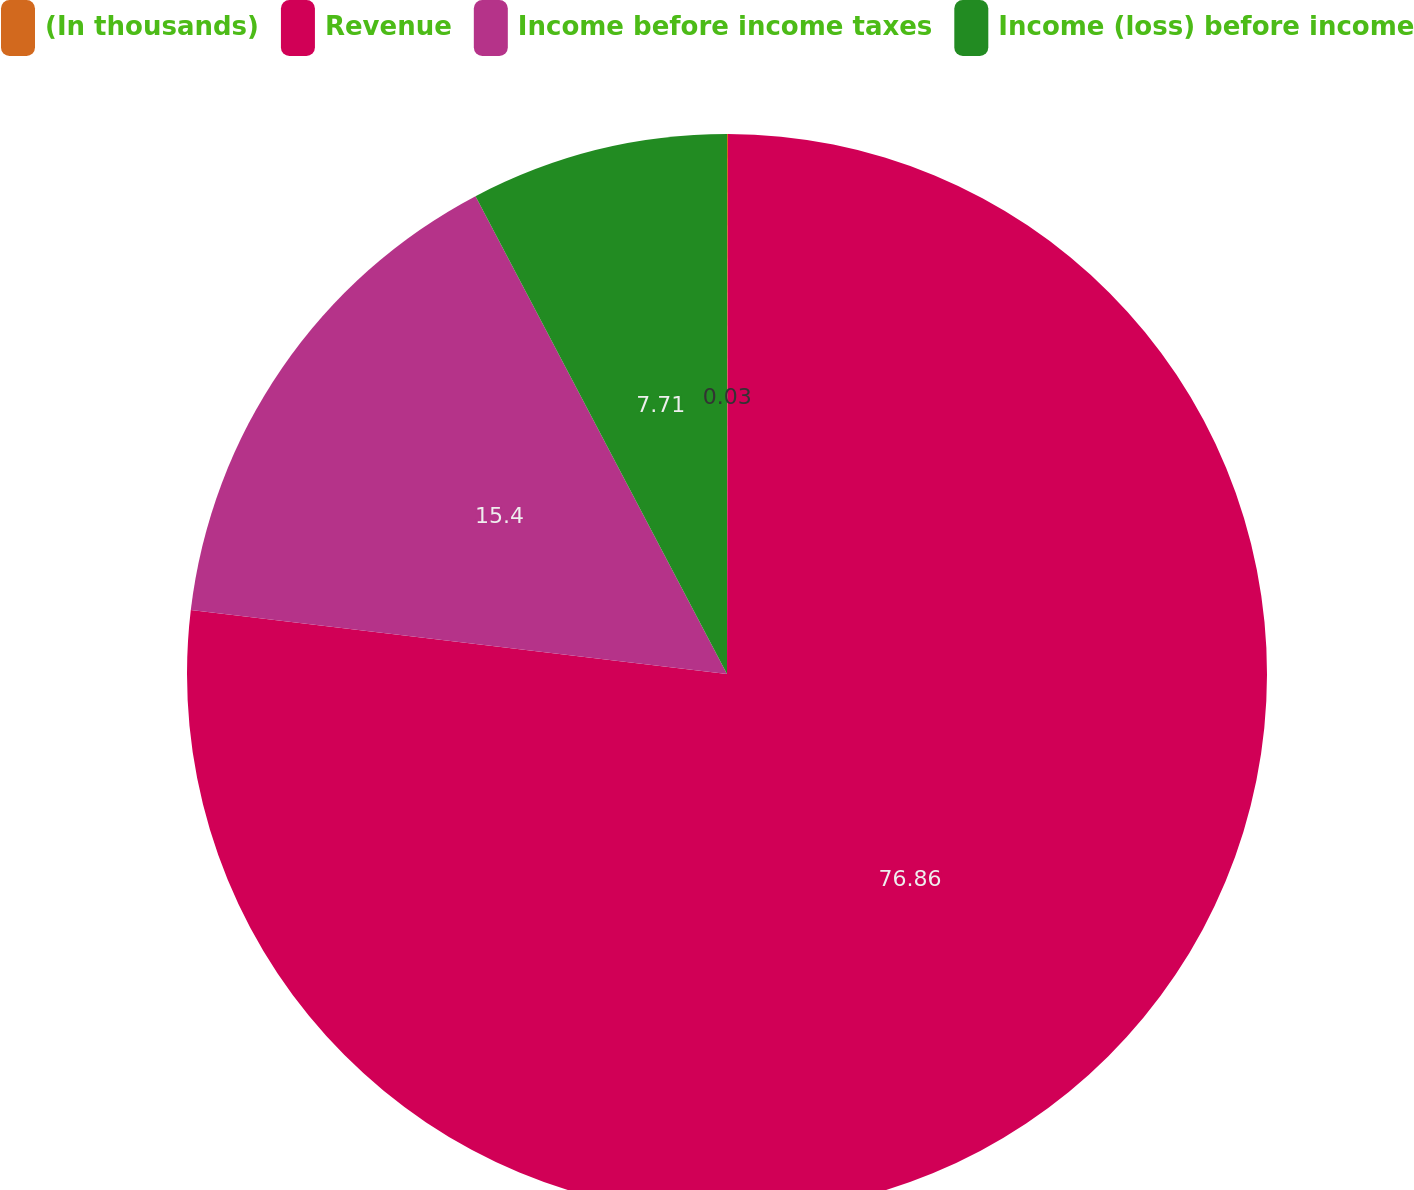Convert chart. <chart><loc_0><loc_0><loc_500><loc_500><pie_chart><fcel>(In thousands)<fcel>Revenue<fcel>Income before income taxes<fcel>Income (loss) before income<nl><fcel>0.03%<fcel>76.86%<fcel>15.4%<fcel>7.71%<nl></chart> 